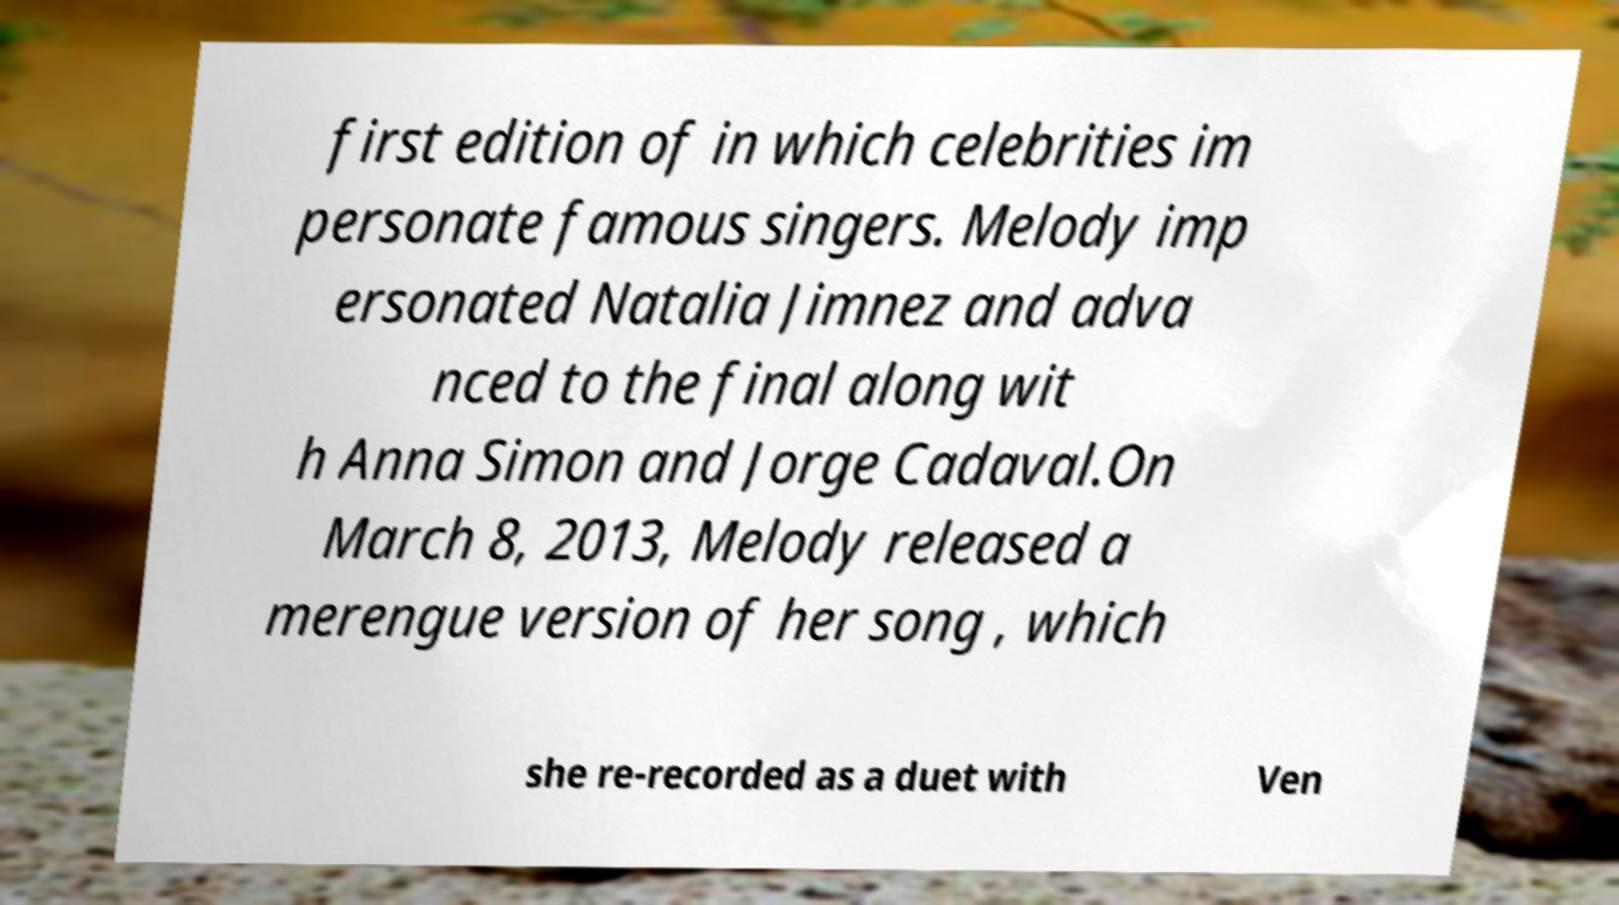I need the written content from this picture converted into text. Can you do that? first edition of in which celebrities im personate famous singers. Melody imp ersonated Natalia Jimnez and adva nced to the final along wit h Anna Simon and Jorge Cadaval.On March 8, 2013, Melody released a merengue version of her song , which she re-recorded as a duet with Ven 